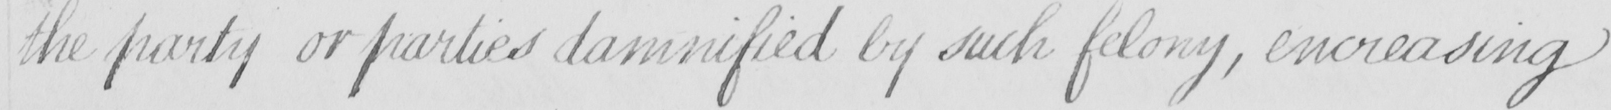What does this handwritten line say? the party or parties damnified by such felony , encreasing 